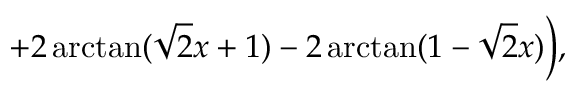<formula> <loc_0><loc_0><loc_500><loc_500>+ 2 \arctan ( \sqrt { 2 } x + 1 ) - 2 \arctan ( 1 - \sqrt { 2 } x ) \Big ) ,</formula> 